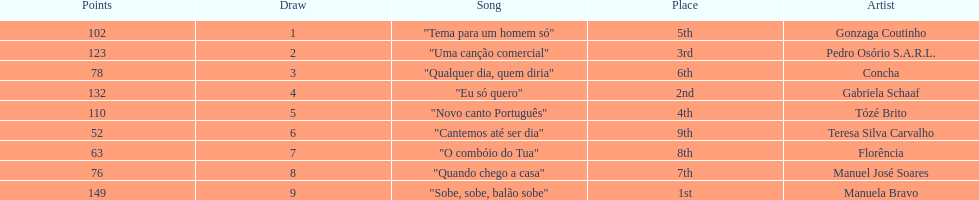Could you help me parse every detail presented in this table? {'header': ['Points', 'Draw', 'Song', 'Place', 'Artist'], 'rows': [['102', '1', '"Tema para um homem só"', '5th', 'Gonzaga Coutinho'], ['123', '2', '"Uma canção comercial"', '3rd', 'Pedro Osório S.A.R.L.'], ['78', '3', '"Qualquer dia, quem diria"', '6th', 'Concha'], ['132', '4', '"Eu só quero"', '2nd', 'Gabriela Schaaf'], ['110', '5', '"Novo canto Português"', '4th', 'Tózé Brito'], ['52', '6', '"Cantemos até ser dia"', '9th', 'Teresa Silva Carvalho'], ['63', '7', '"O combóio do Tua"', '8th', 'Florência'], ['76', '8', '"Quando chego a casa"', '7th', 'Manuel José Soares'], ['149', '9', '"Sobe, sobe, balão sobe"', '1st', 'Manuela Bravo']]} Who was the last draw? Manuela Bravo. 